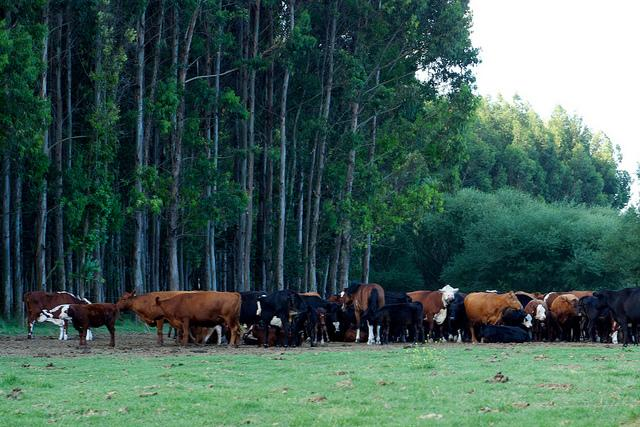What animal are these? Please explain your reasoning. cow. The other options aren't in the image. they would also be referred to as cattle. 